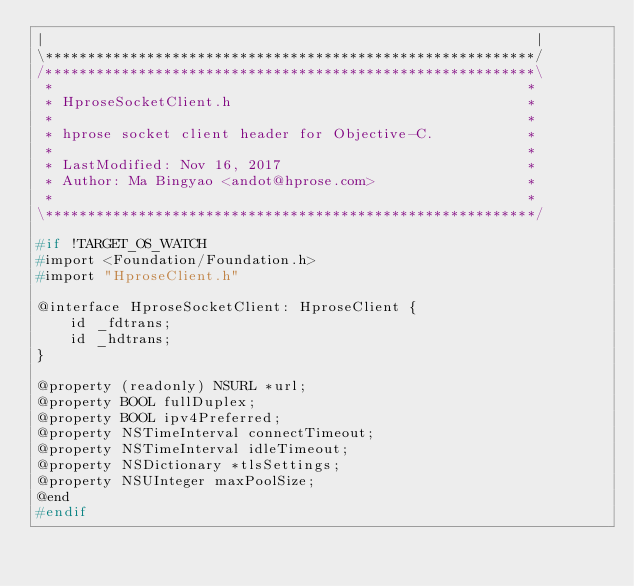<code> <loc_0><loc_0><loc_500><loc_500><_C_>|                                                          |
\**********************************************************/
/**********************************************************\
 *                                                        *
 * HproseSocketClient.h                                   *
 *                                                        *
 * hprose socket client header for Objective-C.           *
 *                                                        *
 * LastModified: Nov 16, 2017                             *
 * Author: Ma Bingyao <andot@hprose.com>                  *
 *                                                        *
\**********************************************************/

#if !TARGET_OS_WATCH
#import <Foundation/Foundation.h>
#import "HproseClient.h"

@interface HproseSocketClient: HproseClient {
    id _fdtrans;
    id _hdtrans;
}

@property (readonly) NSURL *url;
@property BOOL fullDuplex;
@property BOOL ipv4Preferred;
@property NSTimeInterval connectTimeout;
@property NSTimeInterval idleTimeout;
@property NSDictionary *tlsSettings;
@property NSUInteger maxPoolSize;
@end
#endif
</code> 